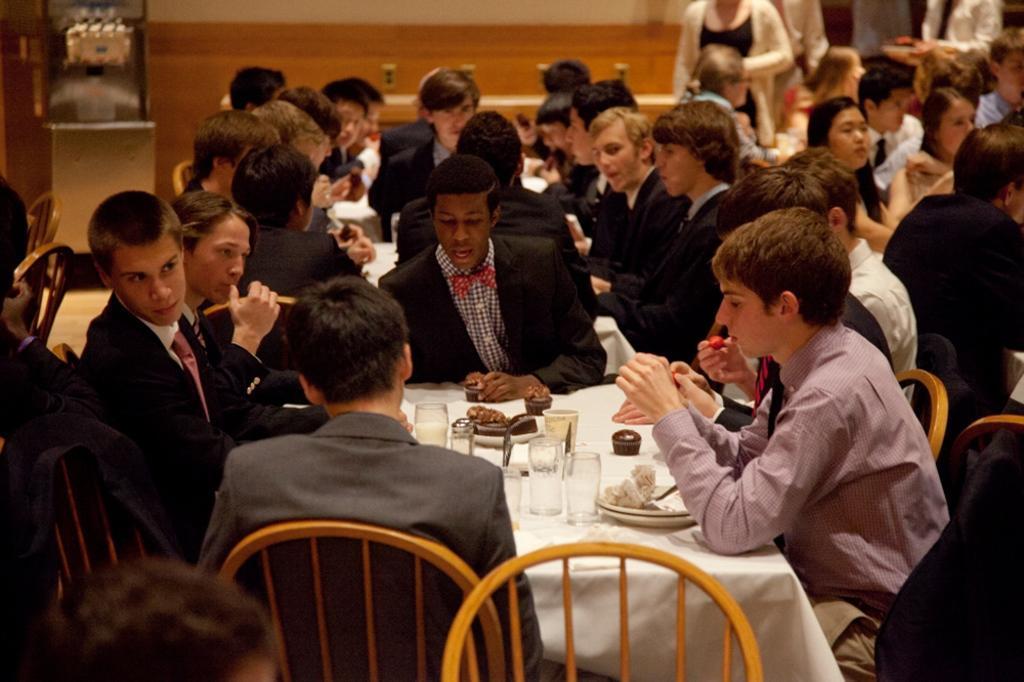Could you give a brief overview of what you see in this image? In this picture there a group of people sitting, they have a table in front of them. 